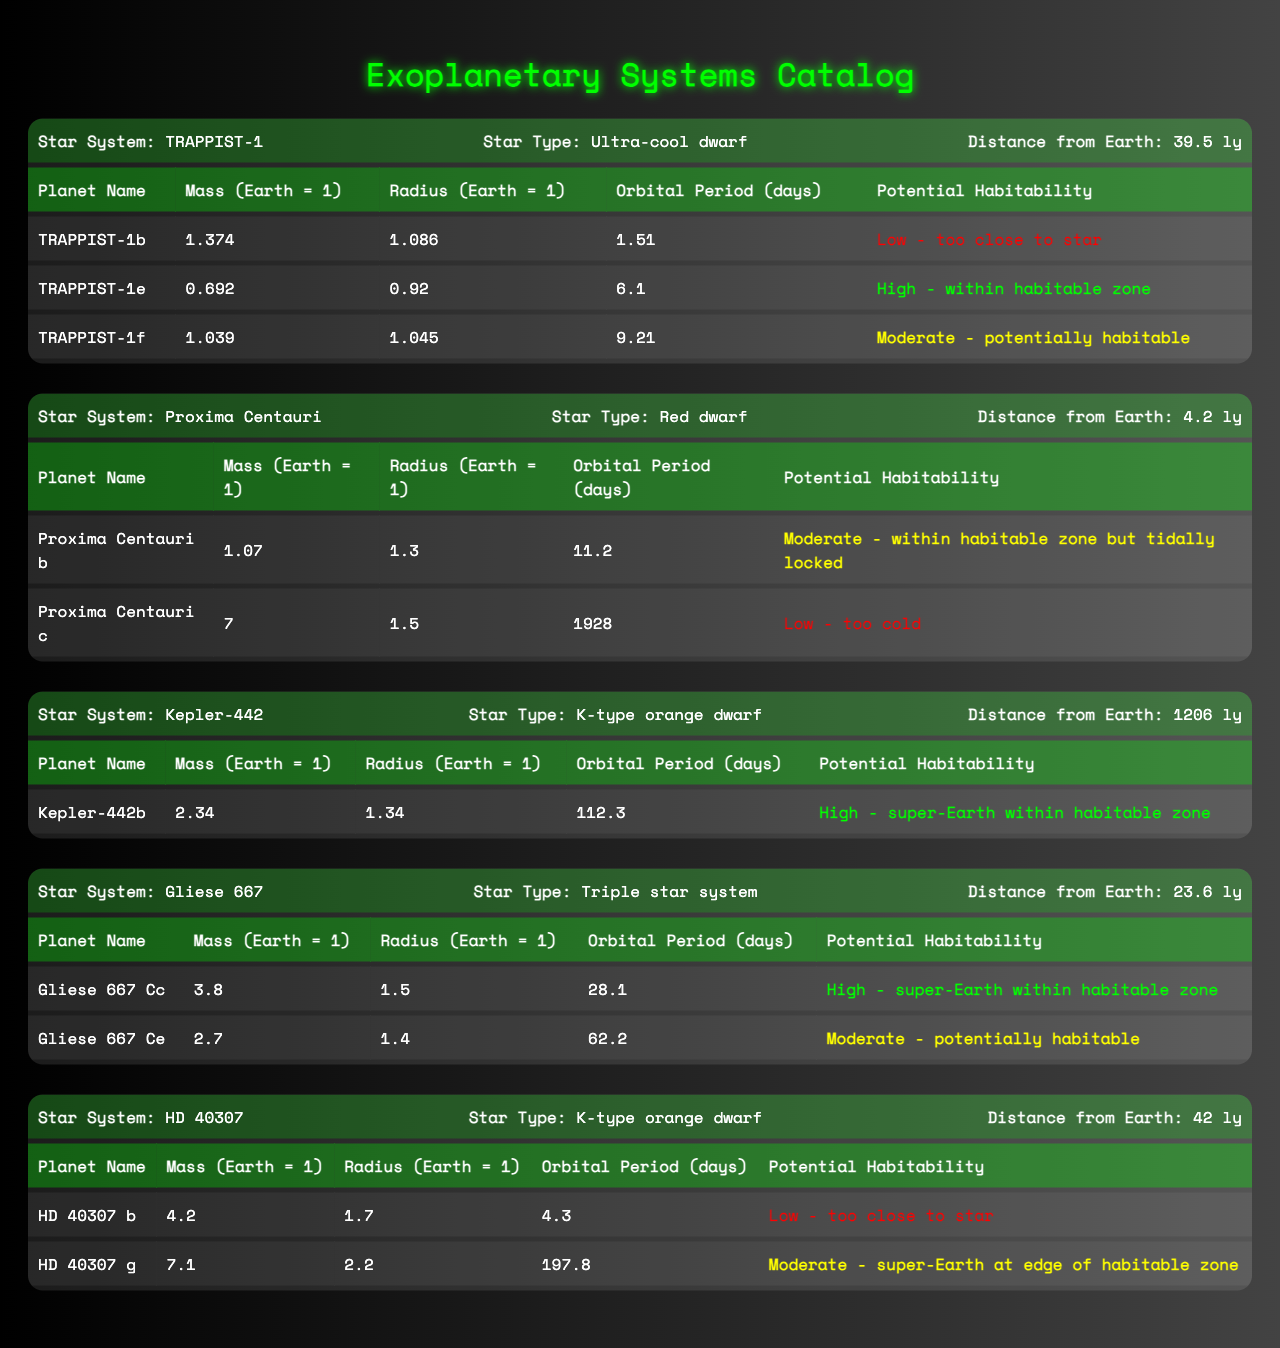What is the distance from Earth to Proxima Centauri? The distance from Earth to Proxima Centauri is clearly listed in the table as 4.2 light-years (ly) under the "Distance from Earth" column for the Proxima Centauri star system.
Answer: 4.2 ly Which exoplanet in the TRAPPIST-1 system has the highest potential habitability? In the TRAPPIST-1 system, the potential habitability for each planet is shown. TRAPPIST-1e has the highest potential habitability classified as "High - within habitable zone."
Answer: TRAPPIST-1e How many planets in Gliese 667 system have a moderate potential habitability rating? In the Gliese 667 system, there are two planets listed. Gliese 667 Ce is rated as "Moderate - potentially habitable." Thus, there is one planet with a moderate rating.
Answer: 1 What is the average mass of the planets in the HD 40307 system? The planets in the HD 40307 system, namely HD 40307 b (mass 4.2) and HD 40307 g (mass 7.1), have their masses added together: 4.2 + 7.1 = 11.3. There are 2 planets, so the average mass is 11.3/2 = 5.65.
Answer: 5.65 Is the orbital period of Kepler-442b longer than that of Proxima Centauri b? The orbital period of Kepler-442b is 112.3 days, while Proxima Centauri b has an orbital period of 11.2 days. Since 112.3 is greater than 11.2, the statement is true.
Answer: Yes Which planet has the largest radius in the Star System Gliese 667? In the Gliese 667 system, the planets are Gliese 667 Cc (radius 1.5) and Gliese 667 Ce (radius 1.4). The largest radius is that of Gliese 667 Cc at 1.5.
Answer: Gliese 667 Cc In which star system would you find a planet that is tidally locked? Proxima Centauri b is identified as being tidally locked with the potential habitability rating of "Moderate." This is explicitly mentioned in the table.
Answer: Proxima Centauri What is the total number of planets in the TRAPPIST-1 and Proxima Centauri systems combined? The TRAPPIST-1 system has three planets: TRAPPIST-1b, TRAPPIST-1e, and TRAPPIST-1f. The Proxima Centauri system has two planets: Proxima Centauri b and Proxima Centauri c. Adding them gives us 3 + 2 = 5 planets total.
Answer: 5 Does the star type of Kepler-442 influence the habitability of its planet? The table lists Kepler-442 as a K-type orange dwarf, which is beneficial for habitability as it allows for potentially habitable zones. This can influence the conditions on its planets favorably.
Answer: Yes What is the mass difference between the most massive planet in Gliese 667 and the least massive planet in HD 40307? The most massive planet in Gliese 667 is Gliese 667 Cc with a mass of 3.8, and the least massive planet in HD 40307 is HD 40307 b with a mass of 4.2. The difference is calculated as 4.2 - 3.8 = 0.4.
Answer: 0.4 